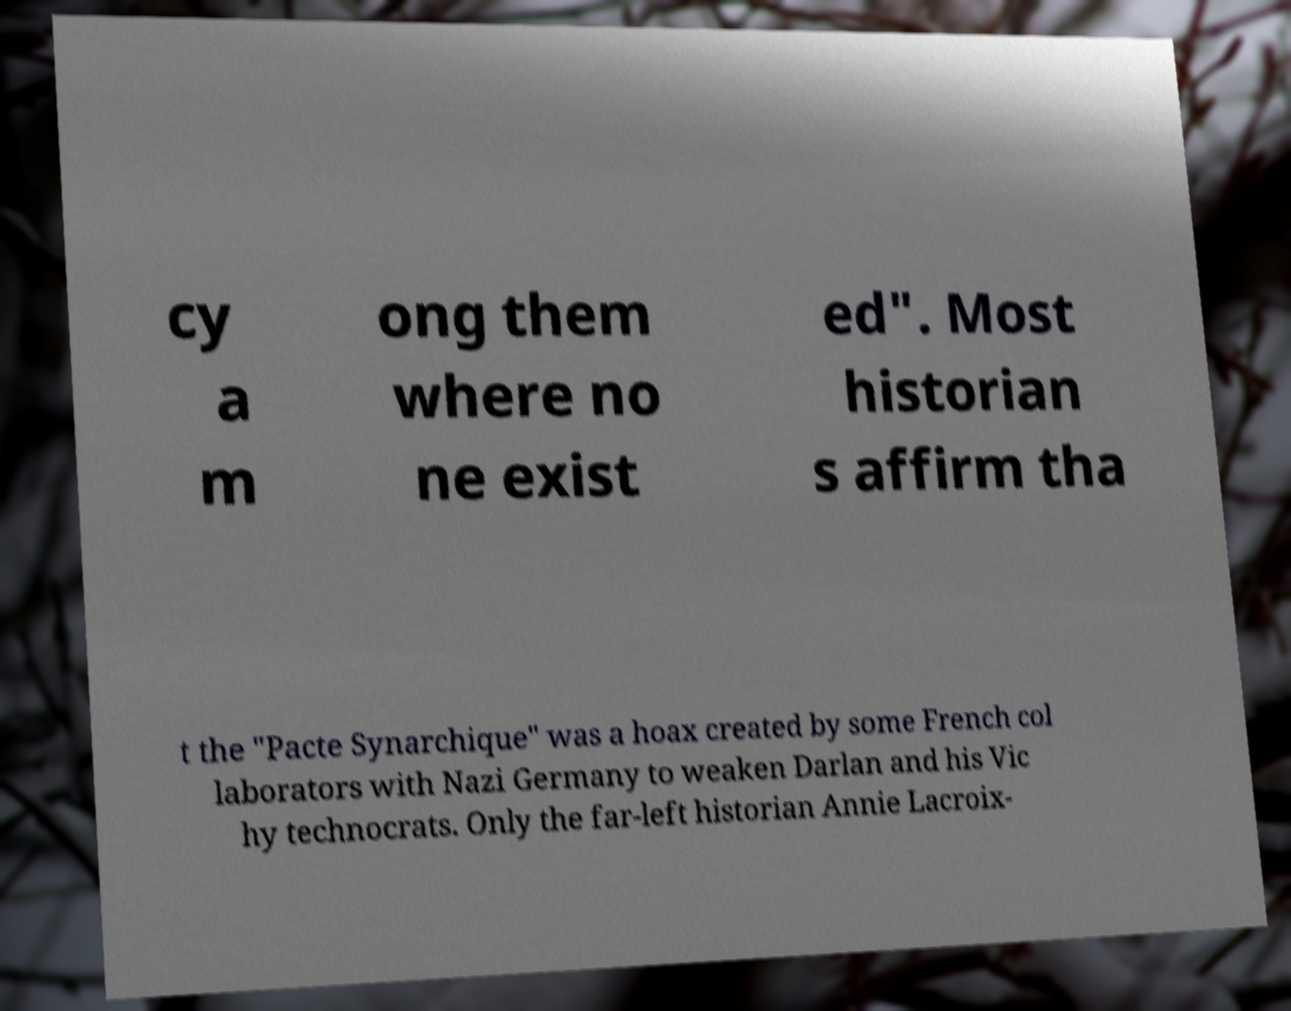There's text embedded in this image that I need extracted. Can you transcribe it verbatim? cy a m ong them where no ne exist ed". Most historian s affirm tha t the "Pacte Synarchique" was a hoax created by some French col laborators with Nazi Germany to weaken Darlan and his Vic hy technocrats. Only the far-left historian Annie Lacroix- 